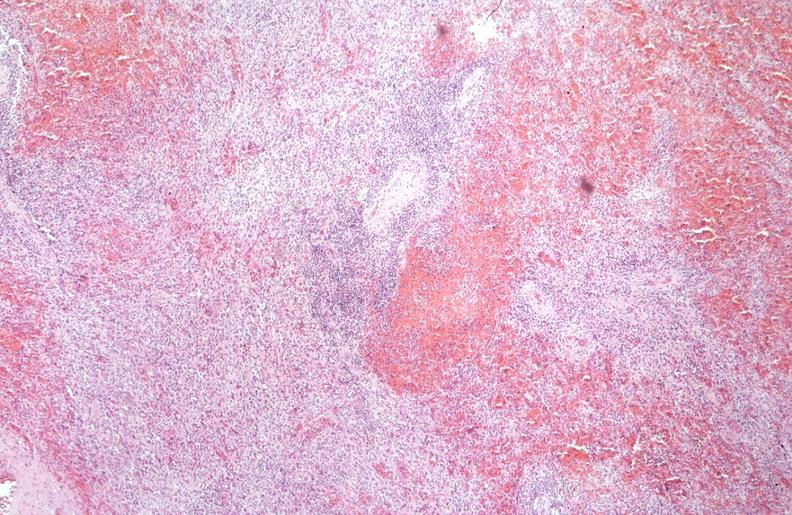why does this image show spleen, chronic congestion?
Answer the question using a single word or phrase. Due to portal hypertension from cirrhosis hcv 